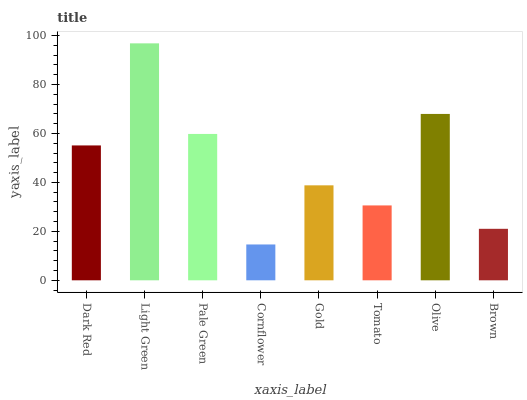Is Cornflower the minimum?
Answer yes or no. Yes. Is Light Green the maximum?
Answer yes or no. Yes. Is Pale Green the minimum?
Answer yes or no. No. Is Pale Green the maximum?
Answer yes or no. No. Is Light Green greater than Pale Green?
Answer yes or no. Yes. Is Pale Green less than Light Green?
Answer yes or no. Yes. Is Pale Green greater than Light Green?
Answer yes or no. No. Is Light Green less than Pale Green?
Answer yes or no. No. Is Dark Red the high median?
Answer yes or no. Yes. Is Gold the low median?
Answer yes or no. Yes. Is Olive the high median?
Answer yes or no. No. Is Dark Red the low median?
Answer yes or no. No. 